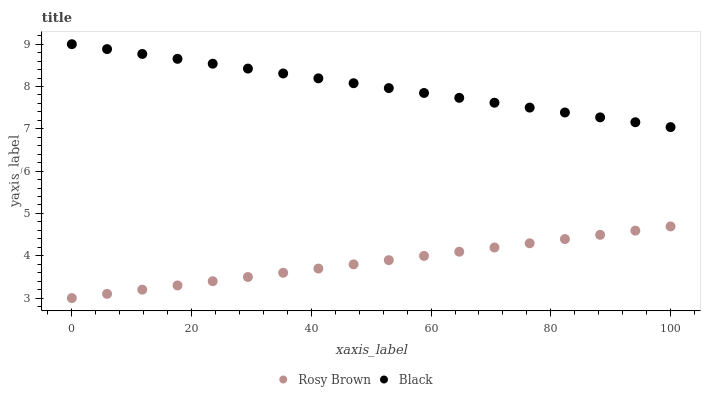Does Rosy Brown have the minimum area under the curve?
Answer yes or no. Yes. Does Black have the maximum area under the curve?
Answer yes or no. Yes. Does Black have the minimum area under the curve?
Answer yes or no. No. Is Rosy Brown the smoothest?
Answer yes or no. Yes. Is Black the roughest?
Answer yes or no. Yes. Is Black the smoothest?
Answer yes or no. No. Does Rosy Brown have the lowest value?
Answer yes or no. Yes. Does Black have the lowest value?
Answer yes or no. No. Does Black have the highest value?
Answer yes or no. Yes. Is Rosy Brown less than Black?
Answer yes or no. Yes. Is Black greater than Rosy Brown?
Answer yes or no. Yes. Does Rosy Brown intersect Black?
Answer yes or no. No. 